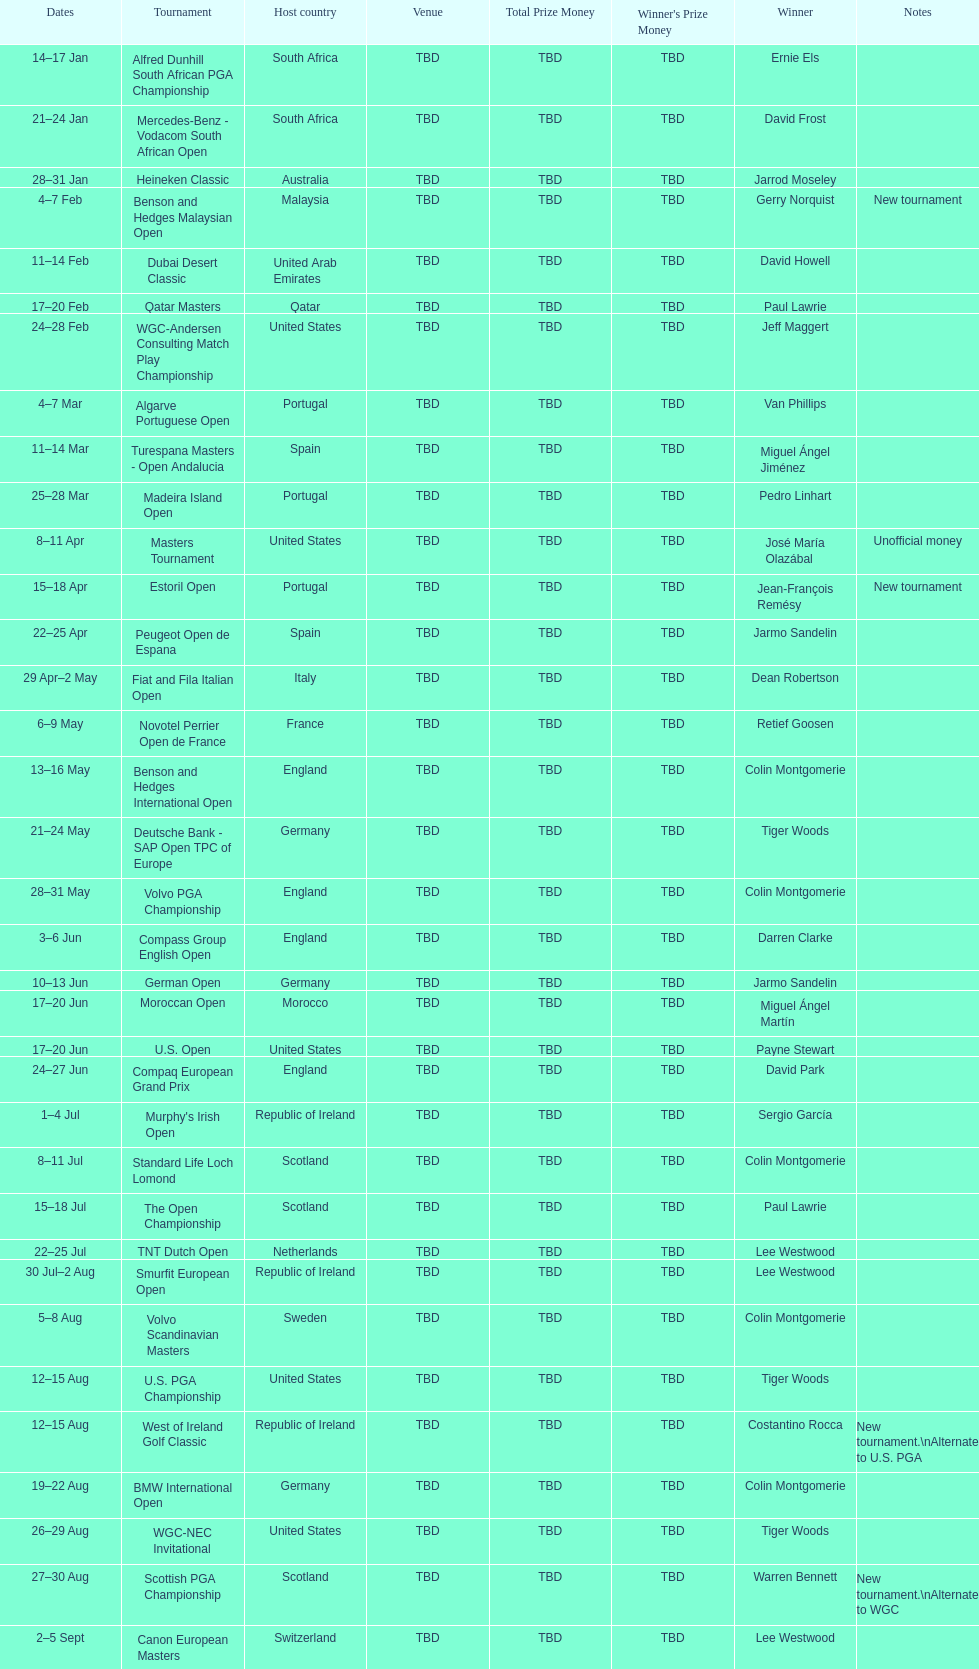How long did the estoril open last? 3 days. 